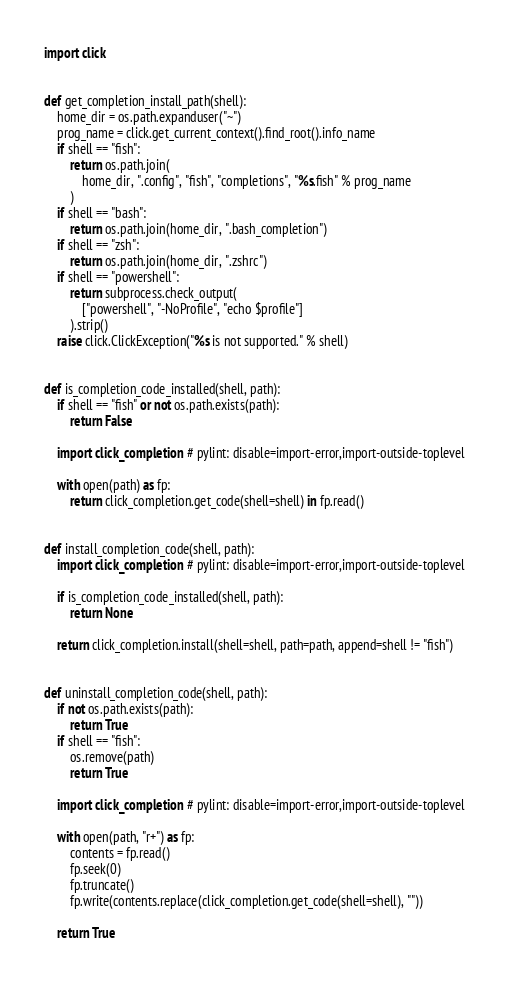<code> <loc_0><loc_0><loc_500><loc_500><_Python_>import click


def get_completion_install_path(shell):
    home_dir = os.path.expanduser("~")
    prog_name = click.get_current_context().find_root().info_name
    if shell == "fish":
        return os.path.join(
            home_dir, ".config", "fish", "completions", "%s.fish" % prog_name
        )
    if shell == "bash":
        return os.path.join(home_dir, ".bash_completion")
    if shell == "zsh":
        return os.path.join(home_dir, ".zshrc")
    if shell == "powershell":
        return subprocess.check_output(
            ["powershell", "-NoProfile", "echo $profile"]
        ).strip()
    raise click.ClickException("%s is not supported." % shell)


def is_completion_code_installed(shell, path):
    if shell == "fish" or not os.path.exists(path):
        return False

    import click_completion  # pylint: disable=import-error,import-outside-toplevel

    with open(path) as fp:
        return click_completion.get_code(shell=shell) in fp.read()


def install_completion_code(shell, path):
    import click_completion  # pylint: disable=import-error,import-outside-toplevel

    if is_completion_code_installed(shell, path):
        return None

    return click_completion.install(shell=shell, path=path, append=shell != "fish")


def uninstall_completion_code(shell, path):
    if not os.path.exists(path):
        return True
    if shell == "fish":
        os.remove(path)
        return True

    import click_completion  # pylint: disable=import-error,import-outside-toplevel

    with open(path, "r+") as fp:
        contents = fp.read()
        fp.seek(0)
        fp.truncate()
        fp.write(contents.replace(click_completion.get_code(shell=shell), ""))

    return True
</code> 